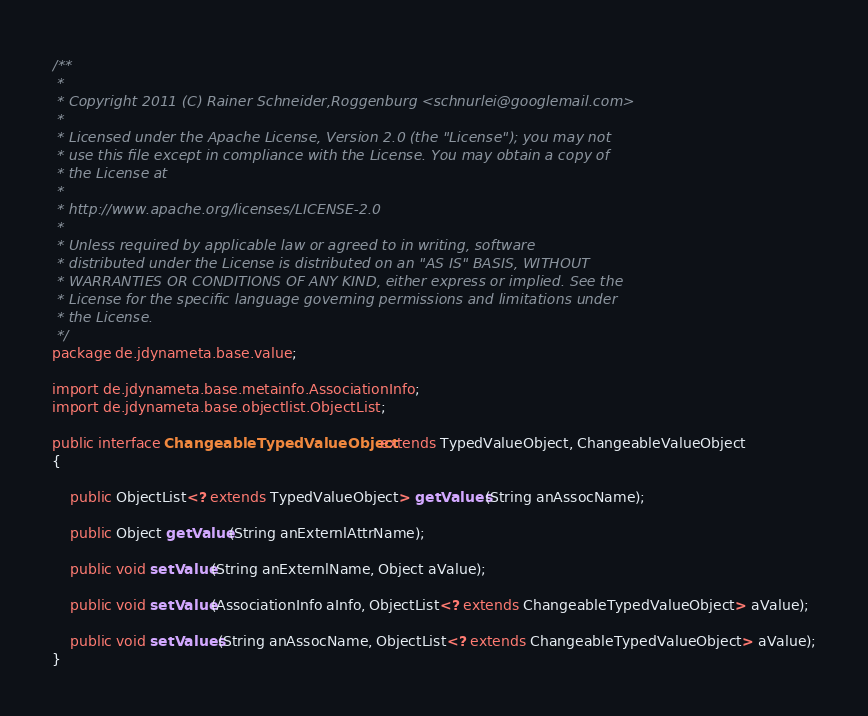<code> <loc_0><loc_0><loc_500><loc_500><_Java_>/**
 *
 * Copyright 2011 (C) Rainer Schneider,Roggenburg <schnurlei@googlemail.com>
 *
 * Licensed under the Apache License, Version 2.0 (the "License"); you may not
 * use this file except in compliance with the License. You may obtain a copy of
 * the License at
 *
 * http://www.apache.org/licenses/LICENSE-2.0
 *
 * Unless required by applicable law or agreed to in writing, software
 * distributed under the License is distributed on an "AS IS" BASIS, WITHOUT
 * WARRANTIES OR CONDITIONS OF ANY KIND, either express or implied. See the
 * License for the specific language governing permissions and limitations under
 * the License.
 */
package de.jdynameta.base.value;

import de.jdynameta.base.metainfo.AssociationInfo;
import de.jdynameta.base.objectlist.ObjectList;

public interface ChangeableTypedValueObject extends TypedValueObject, ChangeableValueObject
{

    public ObjectList<? extends TypedValueObject> getValues(String anAssocName);

    public Object getValue(String anExternlAttrName);

    public void setValue(String anExternlName, Object aValue);

    public void setValue(AssociationInfo aInfo, ObjectList<? extends ChangeableTypedValueObject> aValue);

    public void setValues(String anAssocName, ObjectList<? extends ChangeableTypedValueObject> aValue);
}
</code> 